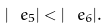<formula> <loc_0><loc_0><loc_500><loc_500>| \ e _ { 5 } | < | \ e _ { 6 } | .</formula> 